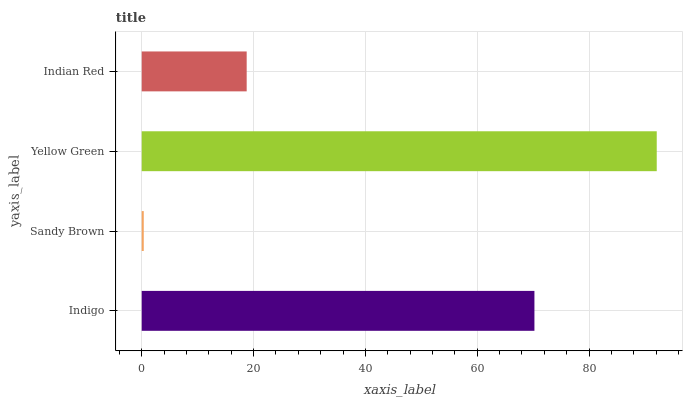Is Sandy Brown the minimum?
Answer yes or no. Yes. Is Yellow Green the maximum?
Answer yes or no. Yes. Is Yellow Green the minimum?
Answer yes or no. No. Is Sandy Brown the maximum?
Answer yes or no. No. Is Yellow Green greater than Sandy Brown?
Answer yes or no. Yes. Is Sandy Brown less than Yellow Green?
Answer yes or no. Yes. Is Sandy Brown greater than Yellow Green?
Answer yes or no. No. Is Yellow Green less than Sandy Brown?
Answer yes or no. No. Is Indigo the high median?
Answer yes or no. Yes. Is Indian Red the low median?
Answer yes or no. Yes. Is Yellow Green the high median?
Answer yes or no. No. Is Indigo the low median?
Answer yes or no. No. 